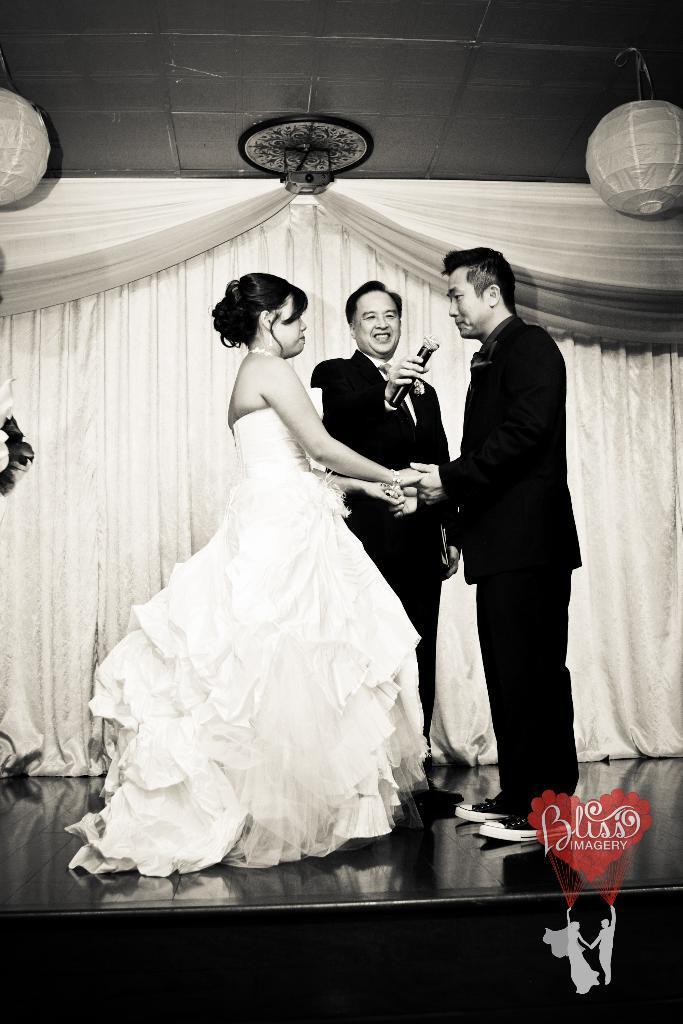Please provide a concise description of this image. In this picture I can observe a woman and a man standing in front of each other and holding their hands. There is another man holding a mic on the stage. In the background I can observe curtains. This is a black and white image. On the bottom right side I can observe a water mark. 